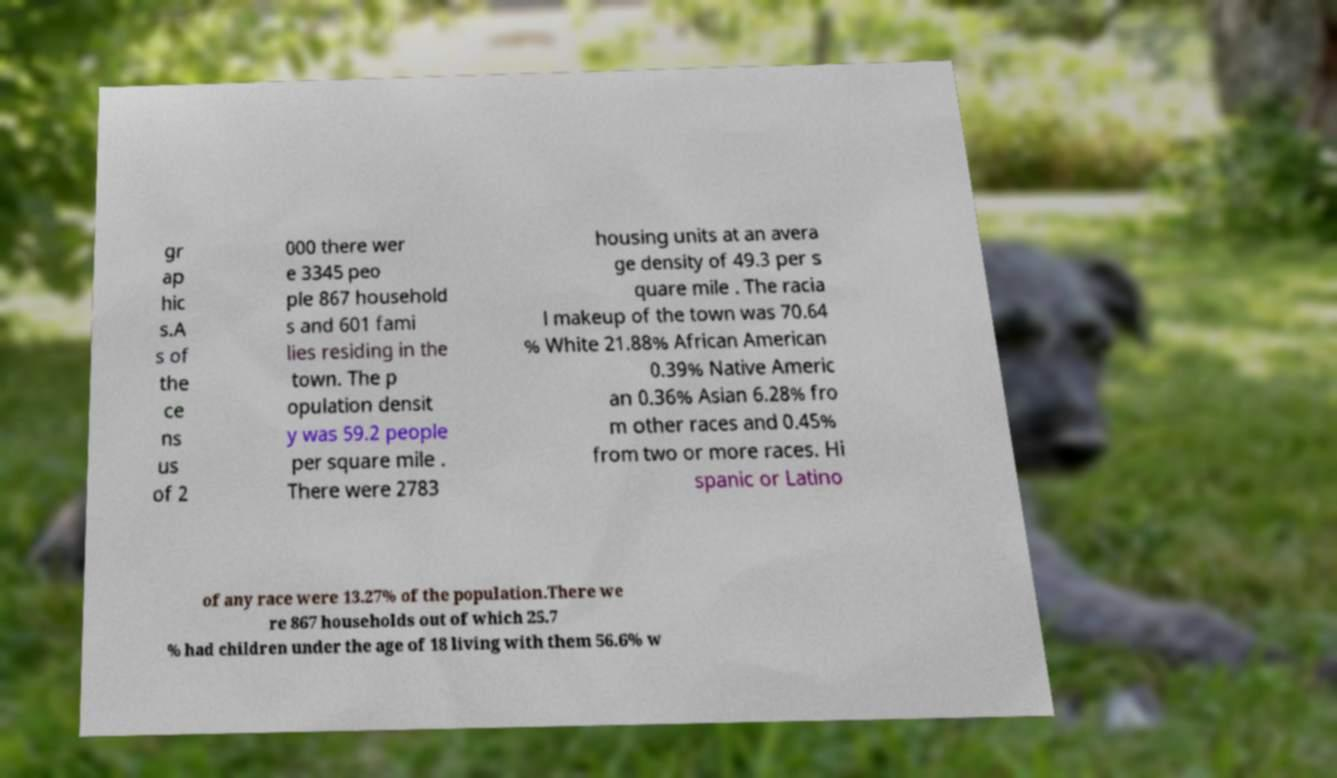Please read and relay the text visible in this image. What does it say? gr ap hic s.A s of the ce ns us of 2 000 there wer e 3345 peo ple 867 household s and 601 fami lies residing in the town. The p opulation densit y was 59.2 people per square mile . There were 2783 housing units at an avera ge density of 49.3 per s quare mile . The racia l makeup of the town was 70.64 % White 21.88% African American 0.39% Native Americ an 0.36% Asian 6.28% fro m other races and 0.45% from two or more races. Hi spanic or Latino of any race were 13.27% of the population.There we re 867 households out of which 25.7 % had children under the age of 18 living with them 56.6% w 